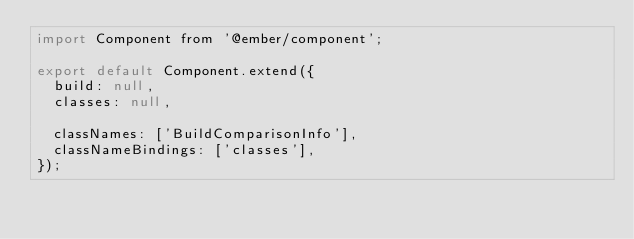<code> <loc_0><loc_0><loc_500><loc_500><_JavaScript_>import Component from '@ember/component';

export default Component.extend({
  build: null,
  classes: null,

  classNames: ['BuildComparisonInfo'],
  classNameBindings: ['classes'],
});
</code> 